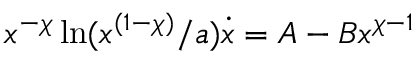<formula> <loc_0><loc_0><loc_500><loc_500>x ^ { - \chi } \ln ( x ^ { ( 1 - \chi ) } / a ) \dot { x } = A - B x ^ { \chi - 1 }</formula> 